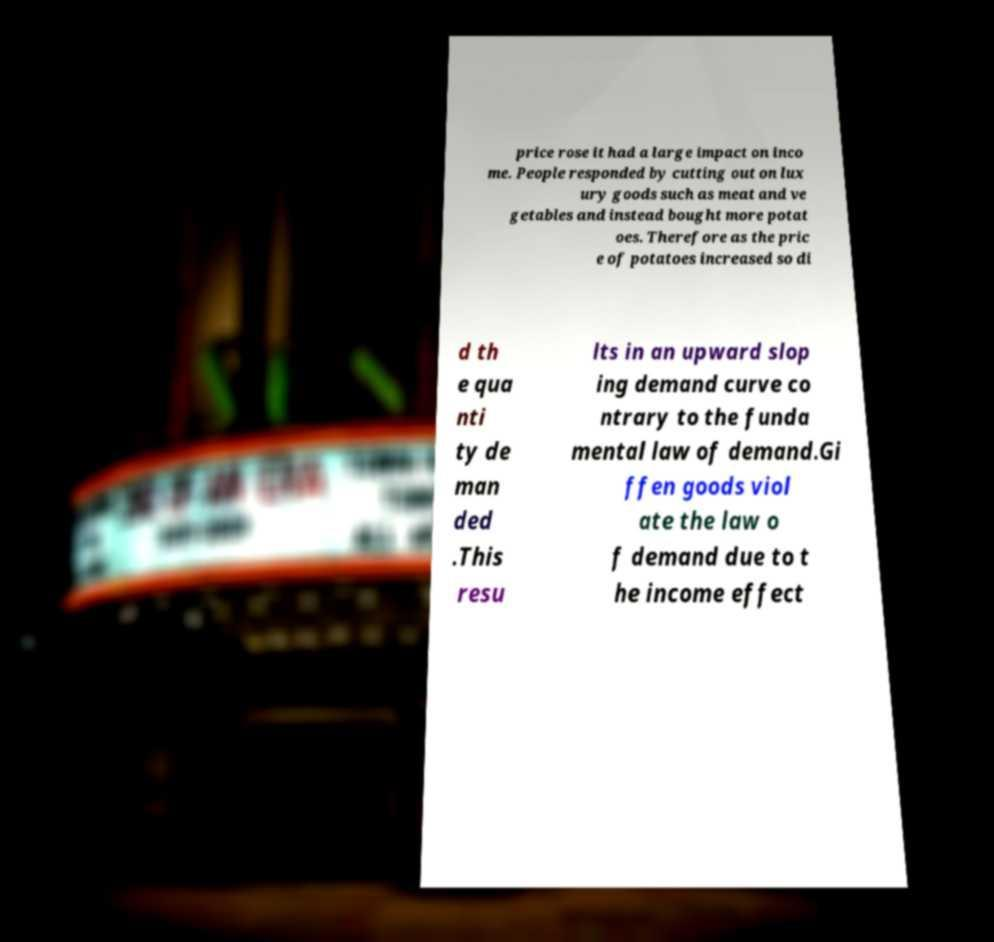For documentation purposes, I need the text within this image transcribed. Could you provide that? price rose it had a large impact on inco me. People responded by cutting out on lux ury goods such as meat and ve getables and instead bought more potat oes. Therefore as the pric e of potatoes increased so di d th e qua nti ty de man ded .This resu lts in an upward slop ing demand curve co ntrary to the funda mental law of demand.Gi ffen goods viol ate the law o f demand due to t he income effect 